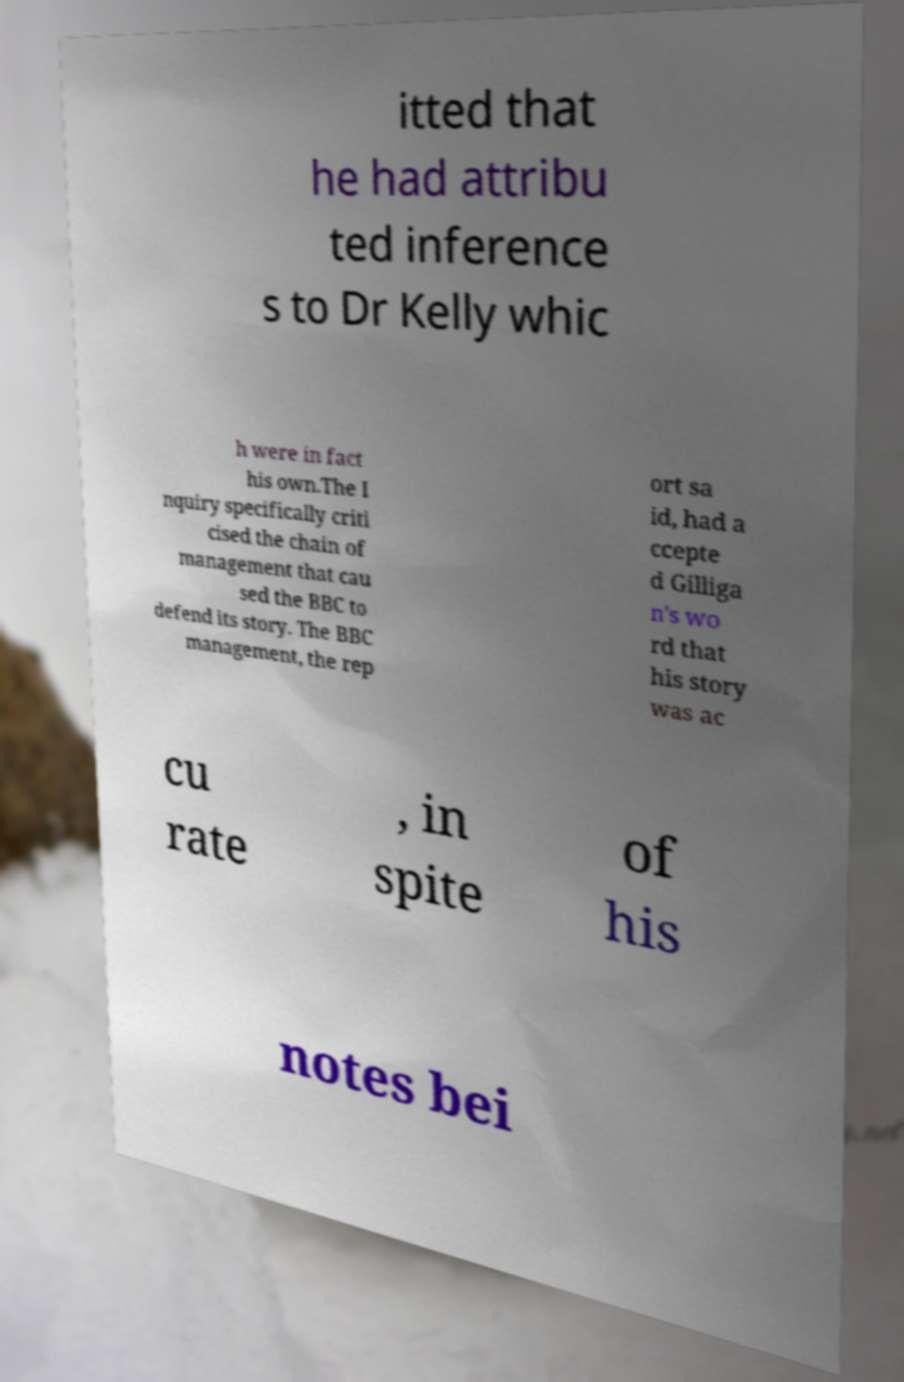Can you accurately transcribe the text from the provided image for me? itted that he had attribu ted inference s to Dr Kelly whic h were in fact his own.The I nquiry specifically criti cised the chain of management that cau sed the BBC to defend its story. The BBC management, the rep ort sa id, had a ccepte d Gilliga n's wo rd that his story was ac cu rate , in spite of his notes bei 